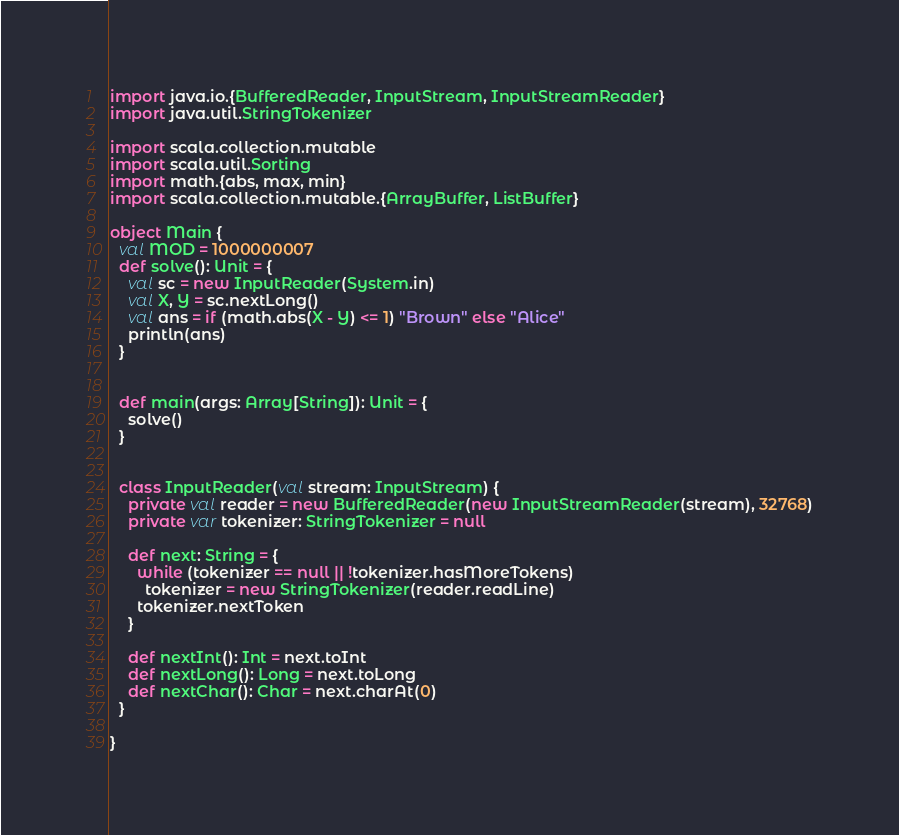<code> <loc_0><loc_0><loc_500><loc_500><_Scala_>import java.io.{BufferedReader, InputStream, InputStreamReader}
import java.util.StringTokenizer

import scala.collection.mutable
import scala.util.Sorting
import math.{abs, max, min}
import scala.collection.mutable.{ArrayBuffer, ListBuffer}

object Main {
  val MOD = 1000000007
  def solve(): Unit = {
    val sc = new InputReader(System.in)
    val X, Y = sc.nextLong()
    val ans = if (math.abs(X - Y) <= 1) "Brown" else "Alice"
    println(ans)
  }


  def main(args: Array[String]): Unit = {
    solve()
  }


  class InputReader(val stream: InputStream) {
    private val reader = new BufferedReader(new InputStreamReader(stream), 32768)
    private var tokenizer: StringTokenizer = null

    def next: String = {
      while (tokenizer == null || !tokenizer.hasMoreTokens)
        tokenizer = new StringTokenizer(reader.readLine)
      tokenizer.nextToken
    }

    def nextInt(): Int = next.toInt
    def nextLong(): Long = next.toLong
    def nextChar(): Char = next.charAt(0)
  }

}
</code> 